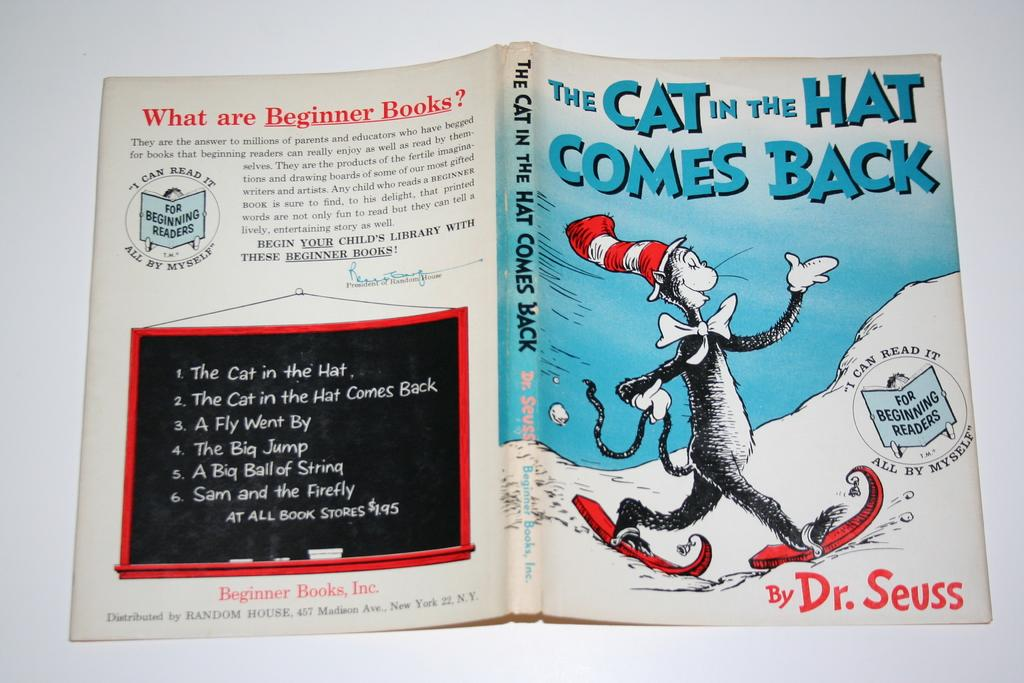<image>
Present a compact description of the photo's key features. The front and back cover of the book The Cat in the Hat Comes Back. 